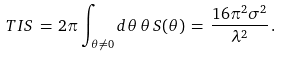Convert formula to latex. <formula><loc_0><loc_0><loc_500><loc_500>T I S \, = \, 2 \pi \int _ { \theta \neq 0 } d \theta \, \theta \, S ( \theta ) \, = \, \frac { 1 6 \pi ^ { 2 } \sigma ^ { 2 } } { \lambda ^ { 2 } } \, .</formula> 